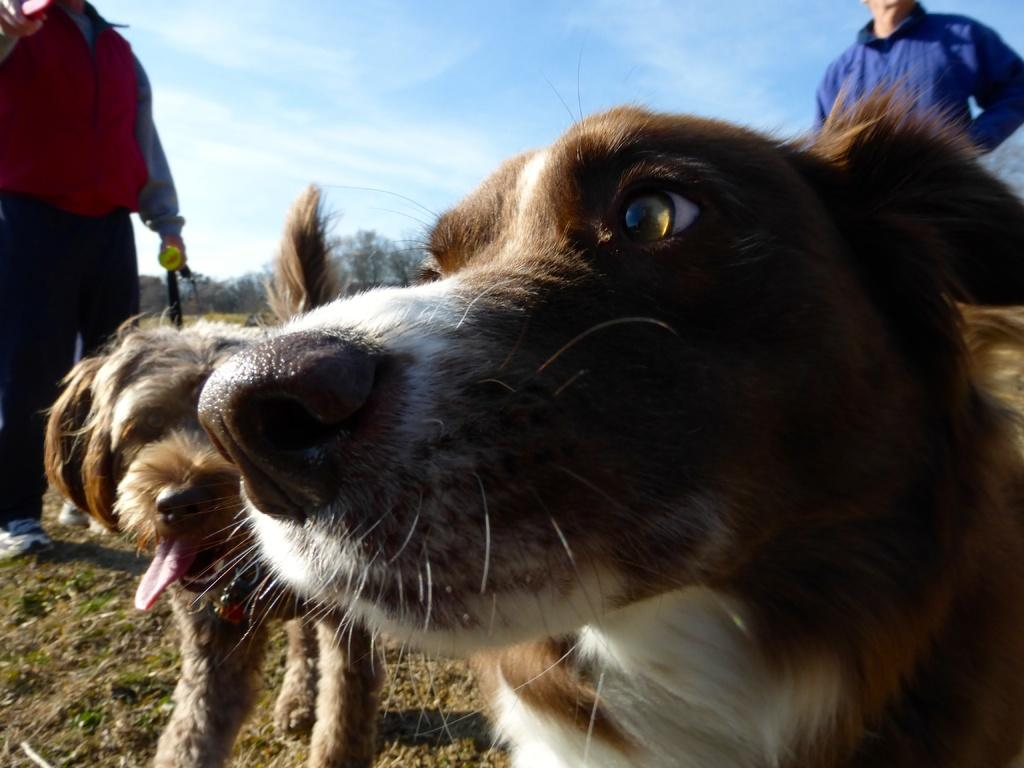How many dogs are in the image? There are 2 dogs in the image. What else can be seen in the background of the image? There are 2 persons standing in the background of the image, as well as the sky and trees. What type of nut is being used to secure the drain in the image? There is no drain or nut present in the image. What is being carried in the sack by one of the dogs in the image? There are no sacks or items being carried by the dogs in the image. 